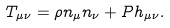<formula> <loc_0><loc_0><loc_500><loc_500>T _ { \mu \nu } = \rho n _ { \mu } n _ { \nu } + P h _ { \mu \nu } .</formula> 